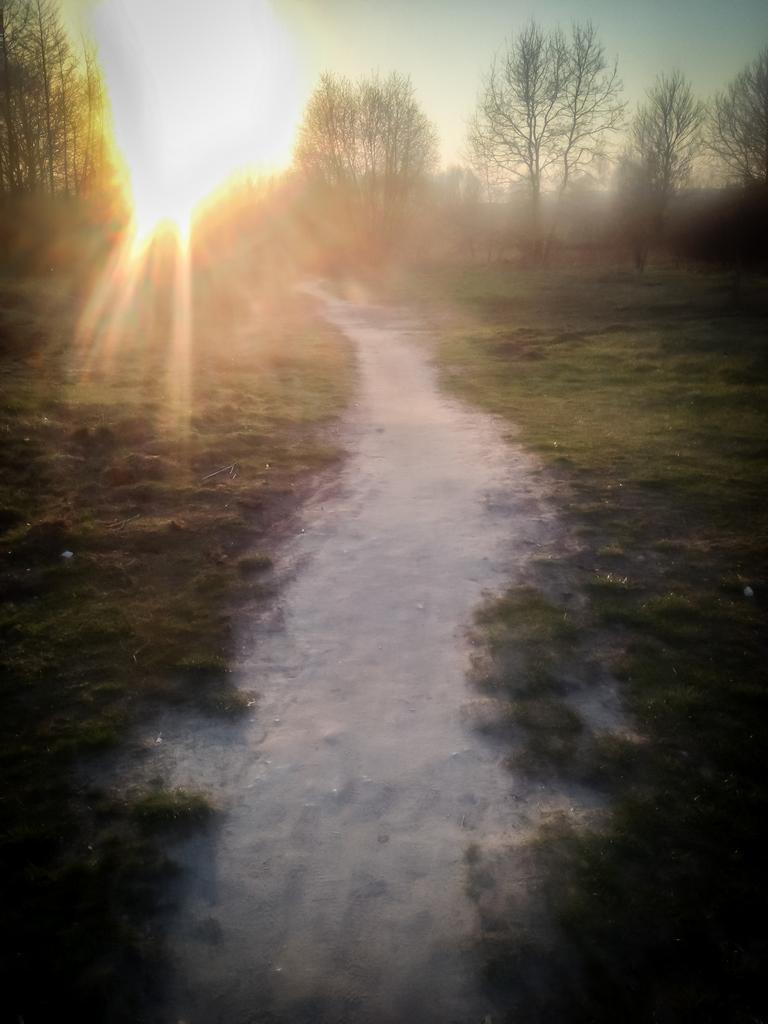In one or two sentences, can you explain what this image depicts? In this image there is grass on the ground. In the center there is a path. In the background there are trees. At the top there is the sky. There is the sun in the sky. 